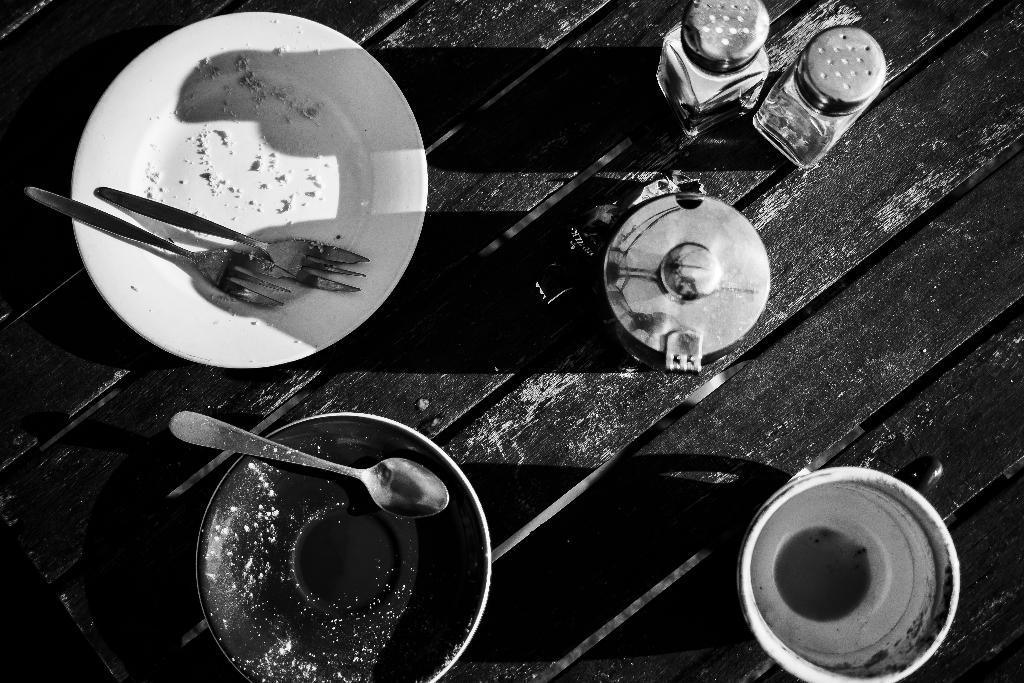What is the color scheme of the image? The image is black and white. What type of surface can be seen in the image? There is a wooden surface in the image. What objects are placed on the wooden surface? There are plates, a bowl, and bottles on the wooden surface. What utensils are on the plates? There are forks and a spoon on the plates. Can you tell me how many goldfish are swimming in the bowl in the image? There is no bowl of water or goldfish present in the image; it features a bowl of a different kind. 